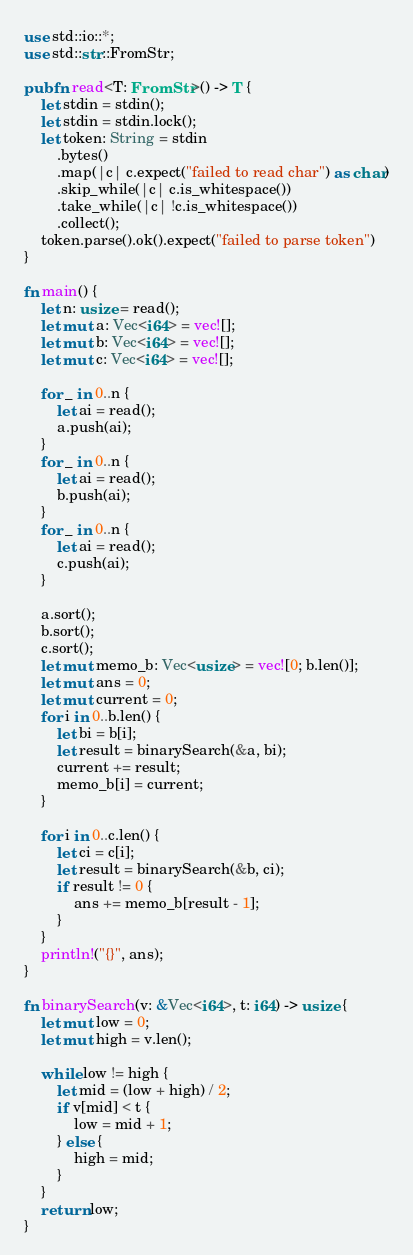<code> <loc_0><loc_0><loc_500><loc_500><_Rust_>use std::io::*;
use std::str::FromStr;

pub fn read<T: FromStr>() -> T {
    let stdin = stdin();
    let stdin = stdin.lock();
    let token: String = stdin
        .bytes()
        .map(|c| c.expect("failed to read char") as char)
        .skip_while(|c| c.is_whitespace())
        .take_while(|c| !c.is_whitespace())
        .collect();
    token.parse().ok().expect("failed to parse token")
}

fn main() {
    let n: usize = read();
    let mut a: Vec<i64> = vec![];
    let mut b: Vec<i64> = vec![];
    let mut c: Vec<i64> = vec![];

    for _ in 0..n {
        let ai = read();
        a.push(ai);
    }
    for _ in 0..n {
        let ai = read();
        b.push(ai);
    }
    for _ in 0..n {
        let ai = read();
        c.push(ai);
    }

    a.sort();
    b.sort();
    c.sort();
    let mut memo_b: Vec<usize> = vec![0; b.len()];
    let mut ans = 0;
    let mut current = 0;
    for i in 0..b.len() {
        let bi = b[i];
        let result = binarySearch(&a, bi);
        current += result;
        memo_b[i] = current;
    }

    for i in 0..c.len() {
        let ci = c[i];
        let result = binarySearch(&b, ci);
        if result != 0 {
            ans += memo_b[result - 1];
        }
    }
    println!("{}", ans);
}

fn binarySearch(v: &Vec<i64>, t: i64) -> usize {
    let mut low = 0;
    let mut high = v.len();

    while low != high {
        let mid = (low + high) / 2;
        if v[mid] < t {
            low = mid + 1;
        } else {
            high = mid;
        }
    }
    return low;
}
</code> 